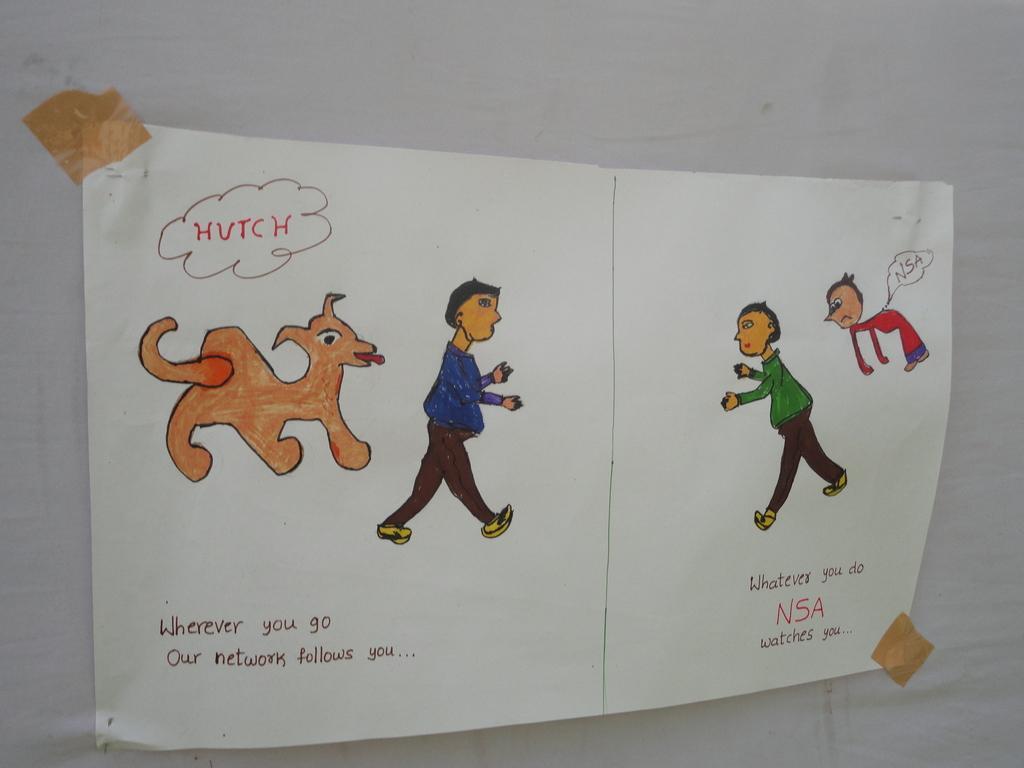Describe this image in one or two sentences. In this image we can see a paper on the surface in which we can see the drawing of some people, a dog and some text on it. 